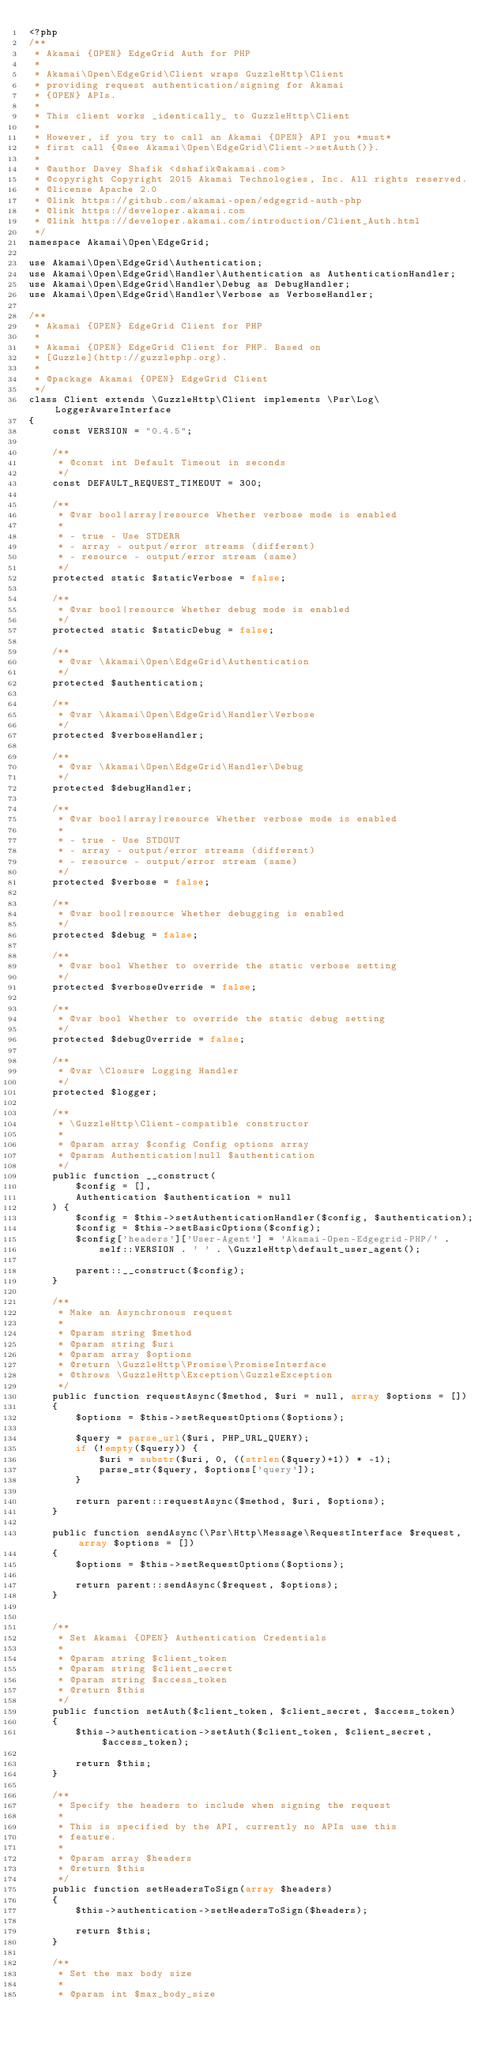<code> <loc_0><loc_0><loc_500><loc_500><_PHP_><?php
/**
 * Akamai {OPEN} EdgeGrid Auth for PHP
 *
 * Akamai\Open\EdgeGrid\Client wraps GuzzleHttp\Client
 * providing request authentication/signing for Akamai
 * {OPEN} APIs.
 *
 * This client works _identically_ to GuzzleHttp\Client
 *
 * However, if you try to call an Akamai {OPEN} API you *must*
 * first call {@see Akamai\Open\EdgeGrid\Client->setAuth()}.
 *
 * @author Davey Shafik <dshafik@akamai.com>
 * @copyright Copyright 2015 Akamai Technologies, Inc. All rights reserved.
 * @license Apache 2.0
 * @link https://github.com/akamai-open/edgegrid-auth-php
 * @link https://developer.akamai.com
 * @link https://developer.akamai.com/introduction/Client_Auth.html
 */
namespace Akamai\Open\EdgeGrid;

use Akamai\Open\EdgeGrid\Authentication;
use Akamai\Open\EdgeGrid\Handler\Authentication as AuthenticationHandler;
use Akamai\Open\EdgeGrid\Handler\Debug as DebugHandler;
use Akamai\Open\EdgeGrid\Handler\Verbose as VerboseHandler;

/**
 * Akamai {OPEN} EdgeGrid Client for PHP
 *
 * Akamai {OPEN} EdgeGrid Client for PHP. Based on
 * [Guzzle](http://guzzlephp.org).
 *
 * @package Akamai {OPEN} EdgeGrid Client
 */
class Client extends \GuzzleHttp\Client implements \Psr\Log\LoggerAwareInterface
{
    const VERSION = "0.4.5";

    /**
     * @const int Default Timeout in seconds
     */
    const DEFAULT_REQUEST_TIMEOUT = 300;

    /**
     * @var bool|array|resource Whether verbose mode is enabled
     *
     * - true - Use STDERR
     * - array - output/error streams (different)
     * - resource - output/error stream (same)
     */
    protected static $staticVerbose = false;

    /**
     * @var bool|resource Whether debug mode is enabled
     */
    protected static $staticDebug = false;

    /**
     * @var \Akamai\Open\EdgeGrid\Authentication
     */
    protected $authentication;

    /**
     * @var \Akamai\Open\EdgeGrid\Handler\Verbose
     */
    protected $verboseHandler;

    /**
     * @var \Akamai\Open\EdgeGrid\Handler\Debug
     */
    protected $debugHandler;

    /**
     * @var bool|array|resource Whether verbose mode is enabled
     *
     * - true - Use STDOUT
     * - array - output/error streams (different)
     * - resource - output/error stream (same)
     */
    protected $verbose = false;

    /**
     * @var bool|resource Whether debugging is enabled
     */
    protected $debug = false;

    /**
     * @var bool Whether to override the static verbose setting
     */
    protected $verboseOverride = false;

    /**
     * @var bool Whether to override the static debug setting
     */
    protected $debugOverride = false;

    /**
     * @var \Closure Logging Handler
     */
    protected $logger;

    /**
     * \GuzzleHttp\Client-compatible constructor
     *
     * @param array $config Config options array
     * @param Authentication|null $authentication
     */
    public function __construct(
        $config = [],
        Authentication $authentication = null
    ) {
        $config = $this->setAuthenticationHandler($config, $authentication);
        $config = $this->setBasicOptions($config);
        $config['headers']['User-Agent'] = 'Akamai-Open-Edgegrid-PHP/' .
            self::VERSION . ' ' . \GuzzleHttp\default_user_agent();

        parent::__construct($config);
    }

    /**
     * Make an Asynchronous request
     *
     * @param string $method
     * @param string $uri
     * @param array $options
     * @return \GuzzleHttp\Promise\PromiseInterface
     * @throws \GuzzleHttp\Exception\GuzzleException
     */
    public function requestAsync($method, $uri = null, array $options = [])
    {
        $options = $this->setRequestOptions($options);

        $query = parse_url($uri, PHP_URL_QUERY);
        if (!empty($query)) {
            $uri = substr($uri, 0, ((strlen($query)+1)) * -1);
            parse_str($query, $options['query']);
        }

        return parent::requestAsync($method, $uri, $options);
    }

    public function sendAsync(\Psr\Http\Message\RequestInterface $request, array $options = [])
    {
        $options = $this->setRequestOptions($options);

        return parent::sendAsync($request, $options);
    }


    /**
     * Set Akamai {OPEN} Authentication Credentials
     *
     * @param string $client_token
     * @param string $client_secret
     * @param string $access_token
     * @return $this
     */
    public function setAuth($client_token, $client_secret, $access_token)
    {
        $this->authentication->setAuth($client_token, $client_secret, $access_token);

        return $this;
    }

    /**
     * Specify the headers to include when signing the request
     *
     * This is specified by the API, currently no APIs use this
     * feature.
     *
     * @param array $headers
     * @return $this
     */
    public function setHeadersToSign(array $headers)
    {
        $this->authentication->setHeadersToSign($headers);

        return $this;
    }

    /**
     * Set the max body size
     *
     * @param int $max_body_size</code> 